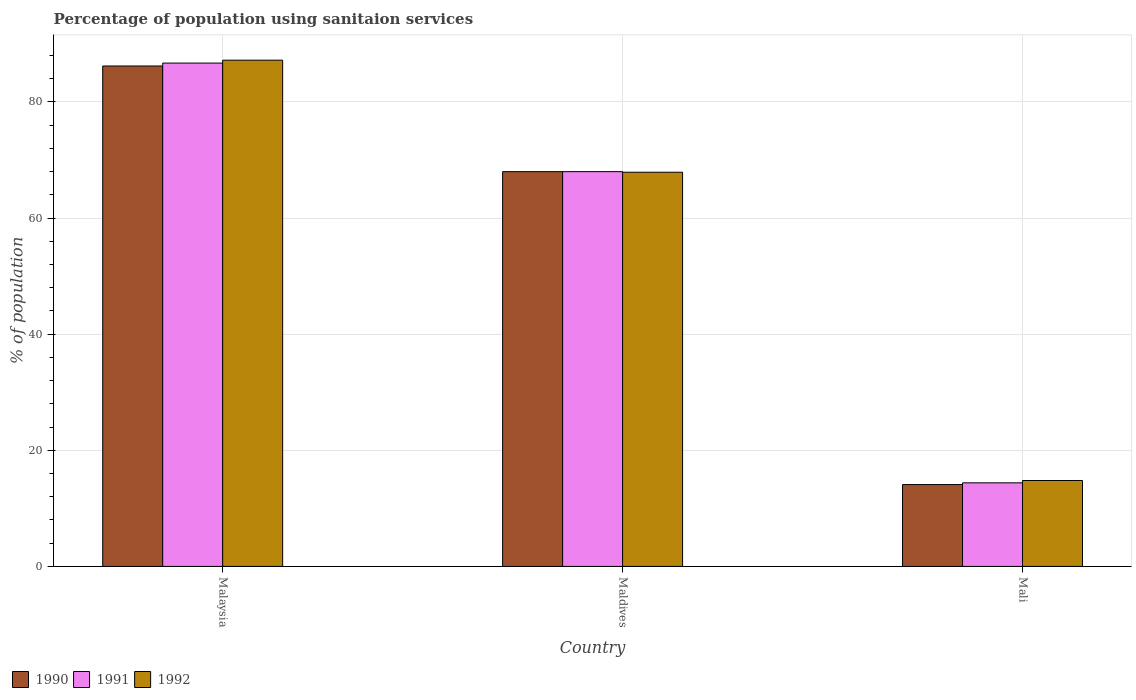How many different coloured bars are there?
Provide a succinct answer. 3. How many groups of bars are there?
Make the answer very short. 3. Are the number of bars per tick equal to the number of legend labels?
Your answer should be very brief. Yes. What is the label of the 1st group of bars from the left?
Offer a very short reply. Malaysia. Across all countries, what is the maximum percentage of population using sanitaion services in 1992?
Provide a short and direct response. 87.2. In which country was the percentage of population using sanitaion services in 1992 maximum?
Make the answer very short. Malaysia. In which country was the percentage of population using sanitaion services in 1992 minimum?
Give a very brief answer. Mali. What is the total percentage of population using sanitaion services in 1990 in the graph?
Give a very brief answer. 168.3. What is the difference between the percentage of population using sanitaion services in 1992 in Maldives and that in Mali?
Your answer should be very brief. 53.1. What is the difference between the percentage of population using sanitaion services in 1992 in Malaysia and the percentage of population using sanitaion services in 1991 in Mali?
Ensure brevity in your answer.  72.8. What is the average percentage of population using sanitaion services in 1990 per country?
Keep it short and to the point. 56.1. What is the difference between the percentage of population using sanitaion services of/in 1991 and percentage of population using sanitaion services of/in 1992 in Maldives?
Offer a very short reply. 0.1. What is the ratio of the percentage of population using sanitaion services in 1990 in Malaysia to that in Mali?
Offer a terse response. 6.11. What is the difference between the highest and the second highest percentage of population using sanitaion services in 1992?
Your response must be concise. 53.1. What is the difference between the highest and the lowest percentage of population using sanitaion services in 1992?
Ensure brevity in your answer.  72.4. In how many countries, is the percentage of population using sanitaion services in 1992 greater than the average percentage of population using sanitaion services in 1992 taken over all countries?
Your response must be concise. 2. Is the sum of the percentage of population using sanitaion services in 1991 in Malaysia and Maldives greater than the maximum percentage of population using sanitaion services in 1992 across all countries?
Provide a short and direct response. Yes. What does the 2nd bar from the left in Maldives represents?
Your response must be concise. 1991. Are all the bars in the graph horizontal?
Offer a very short reply. No. Does the graph contain any zero values?
Provide a short and direct response. No. How are the legend labels stacked?
Provide a short and direct response. Horizontal. What is the title of the graph?
Ensure brevity in your answer.  Percentage of population using sanitaion services. What is the label or title of the Y-axis?
Ensure brevity in your answer.  % of population. What is the % of population of 1990 in Malaysia?
Offer a terse response. 86.2. What is the % of population of 1991 in Malaysia?
Provide a succinct answer. 86.7. What is the % of population of 1992 in Malaysia?
Keep it short and to the point. 87.2. What is the % of population of 1990 in Maldives?
Offer a very short reply. 68. What is the % of population of 1992 in Maldives?
Your response must be concise. 67.9. What is the % of population of 1990 in Mali?
Your response must be concise. 14.1. What is the % of population in 1991 in Mali?
Keep it short and to the point. 14.4. Across all countries, what is the maximum % of population in 1990?
Offer a very short reply. 86.2. Across all countries, what is the maximum % of population of 1991?
Ensure brevity in your answer.  86.7. Across all countries, what is the maximum % of population in 1992?
Provide a succinct answer. 87.2. Across all countries, what is the minimum % of population of 1991?
Make the answer very short. 14.4. What is the total % of population of 1990 in the graph?
Keep it short and to the point. 168.3. What is the total % of population of 1991 in the graph?
Provide a short and direct response. 169.1. What is the total % of population in 1992 in the graph?
Offer a terse response. 169.9. What is the difference between the % of population of 1992 in Malaysia and that in Maldives?
Your answer should be compact. 19.3. What is the difference between the % of population in 1990 in Malaysia and that in Mali?
Keep it short and to the point. 72.1. What is the difference between the % of population of 1991 in Malaysia and that in Mali?
Offer a terse response. 72.3. What is the difference between the % of population of 1992 in Malaysia and that in Mali?
Provide a succinct answer. 72.4. What is the difference between the % of population of 1990 in Maldives and that in Mali?
Make the answer very short. 53.9. What is the difference between the % of population of 1991 in Maldives and that in Mali?
Ensure brevity in your answer.  53.6. What is the difference between the % of population in 1992 in Maldives and that in Mali?
Provide a short and direct response. 53.1. What is the difference between the % of population in 1990 in Malaysia and the % of population in 1991 in Maldives?
Your response must be concise. 18.2. What is the difference between the % of population of 1990 in Malaysia and the % of population of 1991 in Mali?
Ensure brevity in your answer.  71.8. What is the difference between the % of population in 1990 in Malaysia and the % of population in 1992 in Mali?
Give a very brief answer. 71.4. What is the difference between the % of population in 1991 in Malaysia and the % of population in 1992 in Mali?
Provide a succinct answer. 71.9. What is the difference between the % of population in 1990 in Maldives and the % of population in 1991 in Mali?
Your response must be concise. 53.6. What is the difference between the % of population in 1990 in Maldives and the % of population in 1992 in Mali?
Provide a short and direct response. 53.2. What is the difference between the % of population of 1991 in Maldives and the % of population of 1992 in Mali?
Offer a terse response. 53.2. What is the average % of population in 1990 per country?
Offer a very short reply. 56.1. What is the average % of population in 1991 per country?
Your answer should be compact. 56.37. What is the average % of population of 1992 per country?
Give a very brief answer. 56.63. What is the difference between the % of population in 1990 and % of population in 1992 in Malaysia?
Your answer should be compact. -1. What is the difference between the % of population in 1990 and % of population in 1991 in Maldives?
Offer a very short reply. 0. What is the difference between the % of population in 1991 and % of population in 1992 in Maldives?
Your answer should be very brief. 0.1. What is the difference between the % of population of 1990 and % of population of 1992 in Mali?
Provide a succinct answer. -0.7. What is the ratio of the % of population of 1990 in Malaysia to that in Maldives?
Your response must be concise. 1.27. What is the ratio of the % of population in 1991 in Malaysia to that in Maldives?
Provide a succinct answer. 1.27. What is the ratio of the % of population of 1992 in Malaysia to that in Maldives?
Keep it short and to the point. 1.28. What is the ratio of the % of population of 1990 in Malaysia to that in Mali?
Make the answer very short. 6.11. What is the ratio of the % of population in 1991 in Malaysia to that in Mali?
Ensure brevity in your answer.  6.02. What is the ratio of the % of population of 1992 in Malaysia to that in Mali?
Your answer should be very brief. 5.89. What is the ratio of the % of population in 1990 in Maldives to that in Mali?
Your answer should be very brief. 4.82. What is the ratio of the % of population in 1991 in Maldives to that in Mali?
Your answer should be compact. 4.72. What is the ratio of the % of population of 1992 in Maldives to that in Mali?
Provide a succinct answer. 4.59. What is the difference between the highest and the second highest % of population of 1991?
Provide a short and direct response. 18.7. What is the difference between the highest and the second highest % of population of 1992?
Keep it short and to the point. 19.3. What is the difference between the highest and the lowest % of population of 1990?
Give a very brief answer. 72.1. What is the difference between the highest and the lowest % of population of 1991?
Ensure brevity in your answer.  72.3. What is the difference between the highest and the lowest % of population of 1992?
Keep it short and to the point. 72.4. 